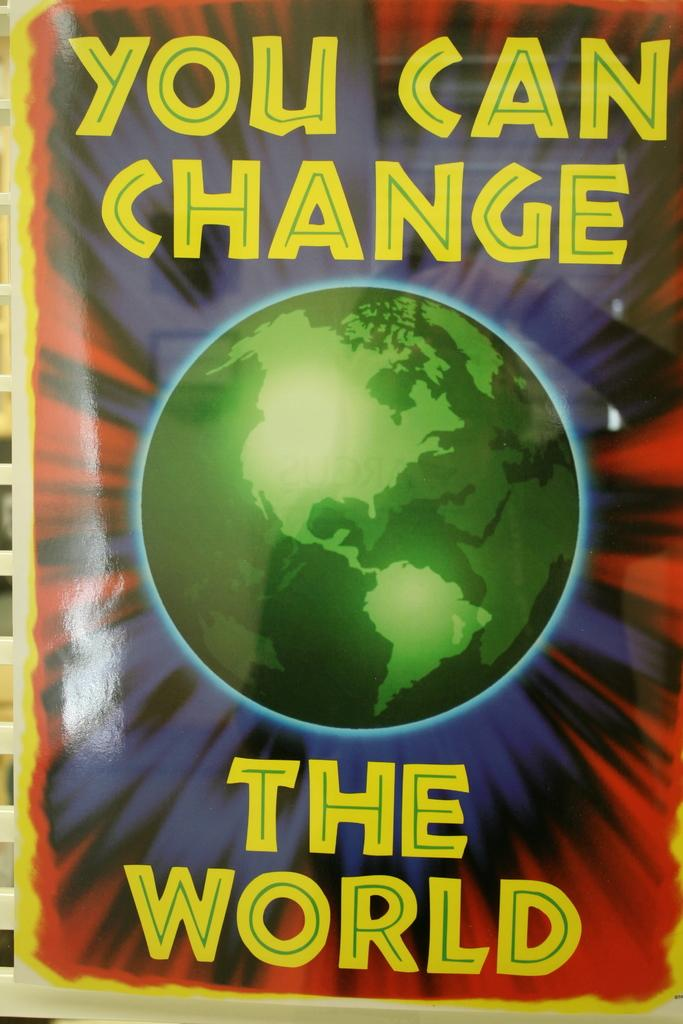<image>
Describe the image concisely. A poster with a globe that says you can change the world. 